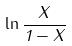Convert formula to latex. <formula><loc_0><loc_0><loc_500><loc_500>\ln \frac { X } { 1 - X }</formula> 